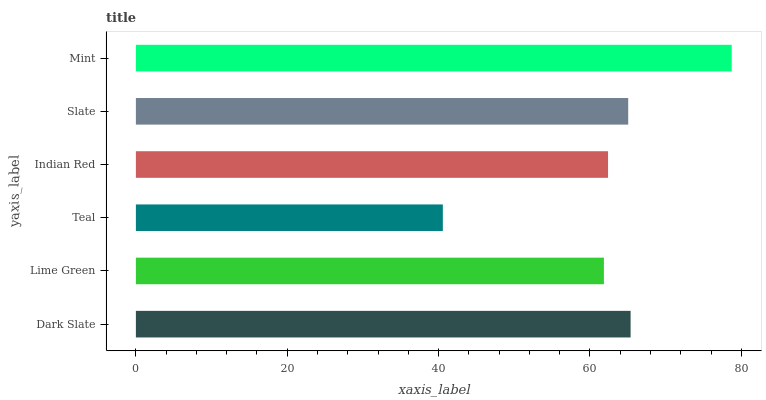Is Teal the minimum?
Answer yes or no. Yes. Is Mint the maximum?
Answer yes or no. Yes. Is Lime Green the minimum?
Answer yes or no. No. Is Lime Green the maximum?
Answer yes or no. No. Is Dark Slate greater than Lime Green?
Answer yes or no. Yes. Is Lime Green less than Dark Slate?
Answer yes or no. Yes. Is Lime Green greater than Dark Slate?
Answer yes or no. No. Is Dark Slate less than Lime Green?
Answer yes or no. No. Is Slate the high median?
Answer yes or no. Yes. Is Indian Red the low median?
Answer yes or no. Yes. Is Indian Red the high median?
Answer yes or no. No. Is Mint the low median?
Answer yes or no. No. 